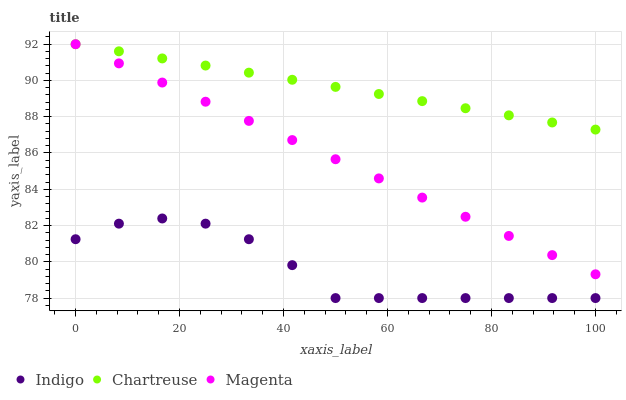Does Indigo have the minimum area under the curve?
Answer yes or no. Yes. Does Chartreuse have the maximum area under the curve?
Answer yes or no. Yes. Does Magenta have the minimum area under the curve?
Answer yes or no. No. Does Magenta have the maximum area under the curve?
Answer yes or no. No. Is Chartreuse the smoothest?
Answer yes or no. Yes. Is Indigo the roughest?
Answer yes or no. Yes. Is Magenta the smoothest?
Answer yes or no. No. Is Magenta the roughest?
Answer yes or no. No. Does Indigo have the lowest value?
Answer yes or no. Yes. Does Magenta have the lowest value?
Answer yes or no. No. Does Magenta have the highest value?
Answer yes or no. Yes. Does Indigo have the highest value?
Answer yes or no. No. Is Indigo less than Magenta?
Answer yes or no. Yes. Is Chartreuse greater than Indigo?
Answer yes or no. Yes. Does Magenta intersect Chartreuse?
Answer yes or no. Yes. Is Magenta less than Chartreuse?
Answer yes or no. No. Is Magenta greater than Chartreuse?
Answer yes or no. No. Does Indigo intersect Magenta?
Answer yes or no. No. 